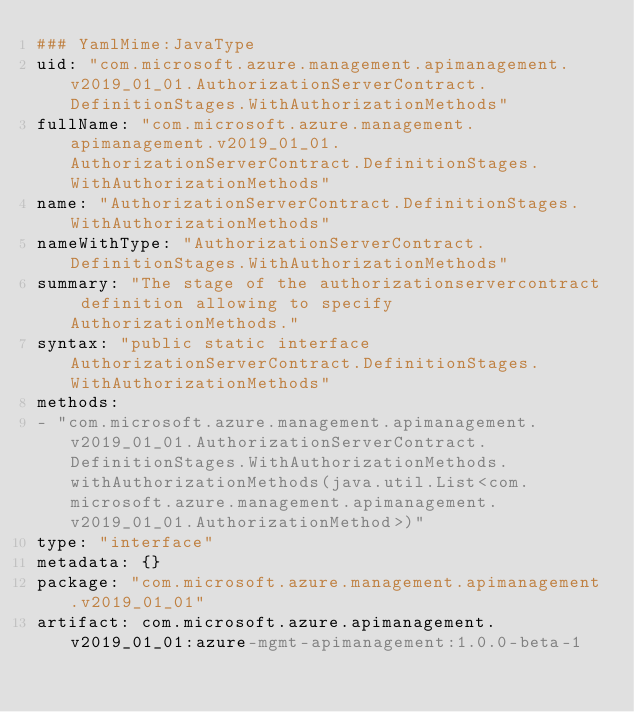<code> <loc_0><loc_0><loc_500><loc_500><_YAML_>### YamlMime:JavaType
uid: "com.microsoft.azure.management.apimanagement.v2019_01_01.AuthorizationServerContract.DefinitionStages.WithAuthorizationMethods"
fullName: "com.microsoft.azure.management.apimanagement.v2019_01_01.AuthorizationServerContract.DefinitionStages.WithAuthorizationMethods"
name: "AuthorizationServerContract.DefinitionStages.WithAuthorizationMethods"
nameWithType: "AuthorizationServerContract.DefinitionStages.WithAuthorizationMethods"
summary: "The stage of the authorizationservercontract definition allowing to specify AuthorizationMethods."
syntax: "public static interface AuthorizationServerContract.DefinitionStages.WithAuthorizationMethods"
methods:
- "com.microsoft.azure.management.apimanagement.v2019_01_01.AuthorizationServerContract.DefinitionStages.WithAuthorizationMethods.withAuthorizationMethods(java.util.List<com.microsoft.azure.management.apimanagement.v2019_01_01.AuthorizationMethod>)"
type: "interface"
metadata: {}
package: "com.microsoft.azure.management.apimanagement.v2019_01_01"
artifact: com.microsoft.azure.apimanagement.v2019_01_01:azure-mgmt-apimanagement:1.0.0-beta-1
</code> 